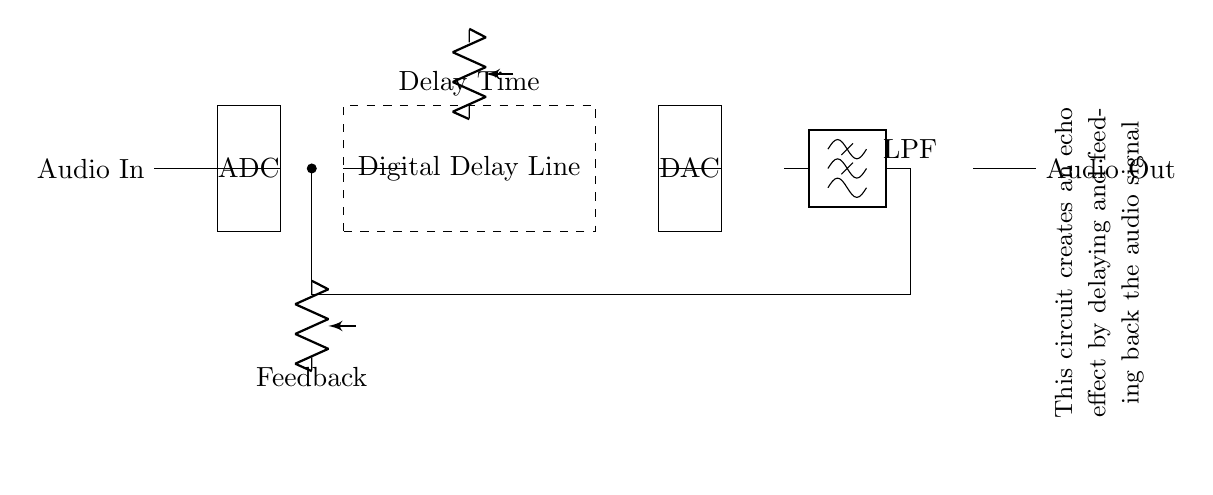What is the purpose of the ADC in this circuit? The ADC converts the analog audio signal into a digital format, allowing it to be processed by the digital delay line.
Answer: Converting signal What does the dashed rectangle represent? The dashed rectangle represents the Digital Delay Line, which is the section of the circuit responsible for delaying the audio signal to create an echo effect.
Answer: Digital Delay Line What component follows the Digital Delay Line? The component that follows the Digital Delay Line is the Digital-to-Analog Converter (DAC), which converts the delayed digital audio signal back into an analog signal.
Answer: DAC What is the function of the feedback path in this circuit? The feedback path allows some of the output signal to be fed back into the circuit, which enhances the echo effect by repeating the delayed sound.
Answer: Enhancing echo How does the control knob for delay time affect this circuit? The control knob for delay time adjusts the duration of the delay applied to the audio signal, impacting how long it takes for the echo to occur after the initial sound.
Answer: Adjusts delay duration What is the overall effect this circuit is designed to create? The overall effect the circuit aims to create is an echo effect in the audio signal, making it sound like the sound is bouncing back from a surface.
Answer: Echo effect 